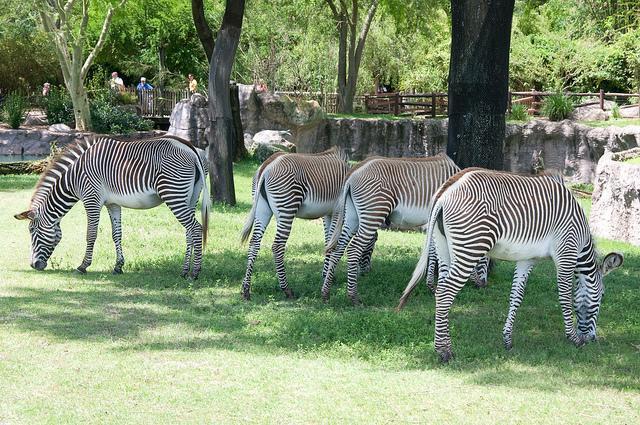How many animals are there?
Give a very brief answer. 4. How many zebras can you see?
Give a very brief answer. 4. 